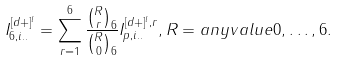Convert formula to latex. <formula><loc_0><loc_0><loc_500><loc_500>I _ { 6 , i . . } ^ { [ d + ] ^ { l } } = \sum ^ { 6 } _ { r = 1 } \frac { { R \choose r } _ { 6 } } { { R \choose 0 } _ { 6 } } I _ { p , i . . } ^ { [ d + ] ^ { l } , r } , R = a n y v a l u e 0 , \dots , 6 .</formula> 